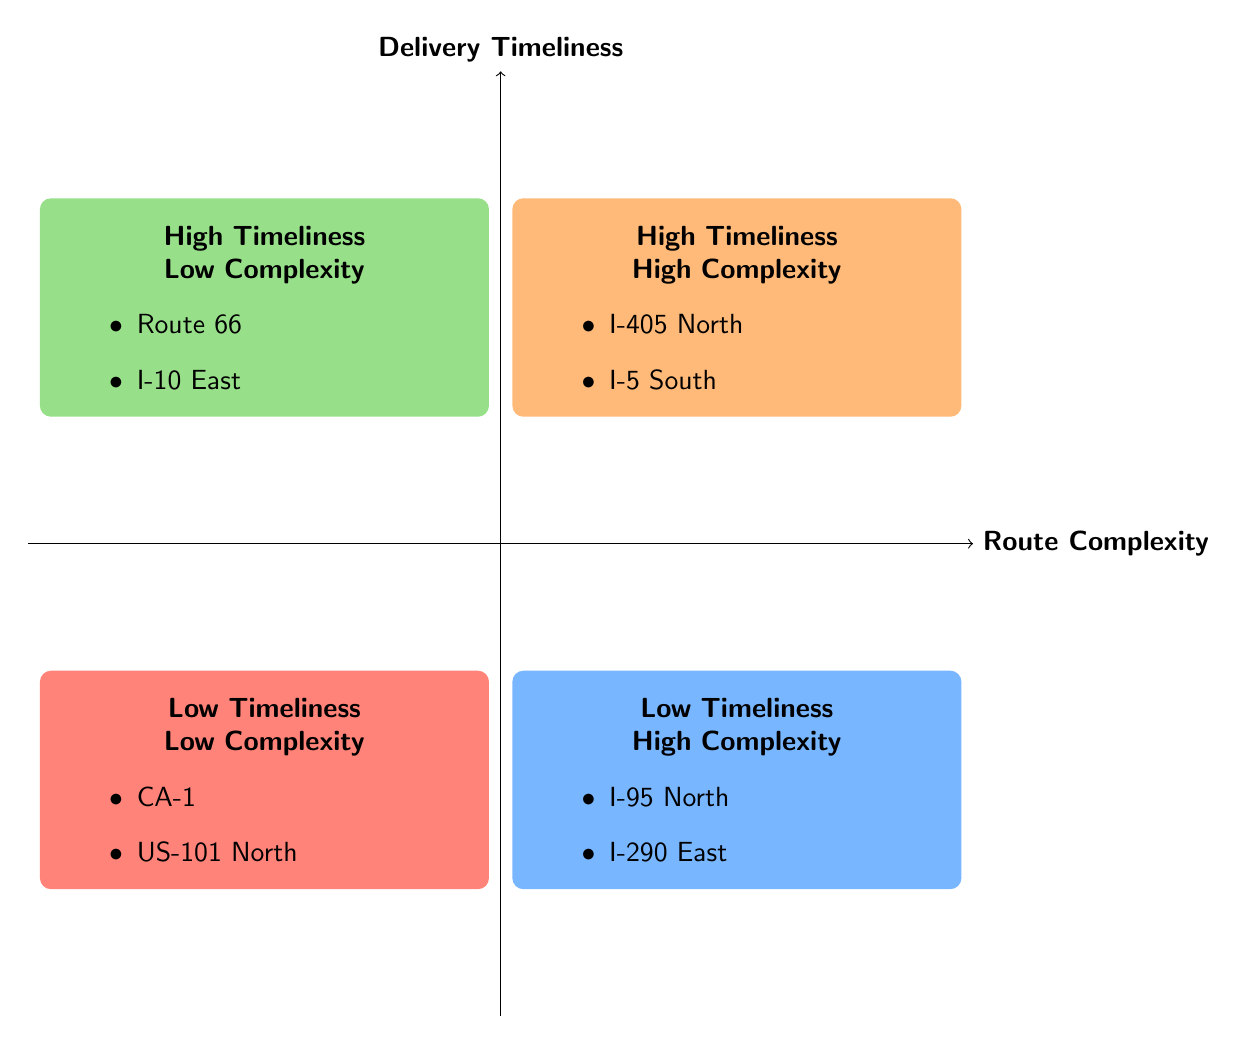What are the routes in the High Timeliness - Low Complexity quadrant? The High Timeliness - Low Complexity quadrant includes two routes: Route 66 and I-10 East. These are listed within the quadrant area.
Answer: Route 66, I-10 East Which quadrant contains I-405 North? I-405 North is listed in the High Timeliness - High Complexity quadrant.
Answer: High Timeliness - High Complexity What is the average delay for US-101 North? US-101 North is located in the Low Timeliness - Low Complexity quadrant, where it has an average delay of 25 minutes. This is explicitly stated within the quadrant details.
Answer: 25 minutes How many routes are in the Low Timeliness - High Complexity quadrant? The Low Timeliness - High Complexity quadrant displays two routes: I-95 North and I-290 East, as indicated in the quadrant’s itemized list.
Answer: 2 What is the traffic level for Route 66? The traffic level for Route 66 is moderate, as mentioned in the example details for this route in the High Timeliness - Low Complexity quadrant.
Answer: Moderate Which route has the highest average delay in the diagram? The highest average delay in the diagram belongs to I-290 East, which has a delay of 35 minutes, found in the Low Timeliness - High Complexity quadrant.
Answer: I-290 East What can you infer about routes with heavy traffic? Routes with heavy traffic tend to be in either the High Complexity or Low Timeliness quadrants, such as I-405 North and I-95 North, showing a relationship between heavy traffic and route complexity or delayed timings.
Answer: High Complexity, Low Timeliness What is common between I-10 East and I-5 South? Both I-10 East and I-5 South are in the quadrant for High Timeliness, indicating they deliver goods on time despite different complexities, reflecting efficiency.
Answer: High Timeliness 